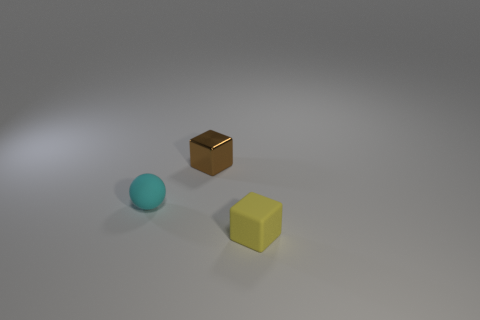Add 3 small red shiny objects. How many objects exist? 6 Subtract all balls. How many objects are left? 2 Subtract all big cyan shiny balls. Subtract all yellow rubber cubes. How many objects are left? 2 Add 1 matte spheres. How many matte spheres are left? 2 Add 3 gray objects. How many gray objects exist? 3 Subtract 0 gray spheres. How many objects are left? 3 